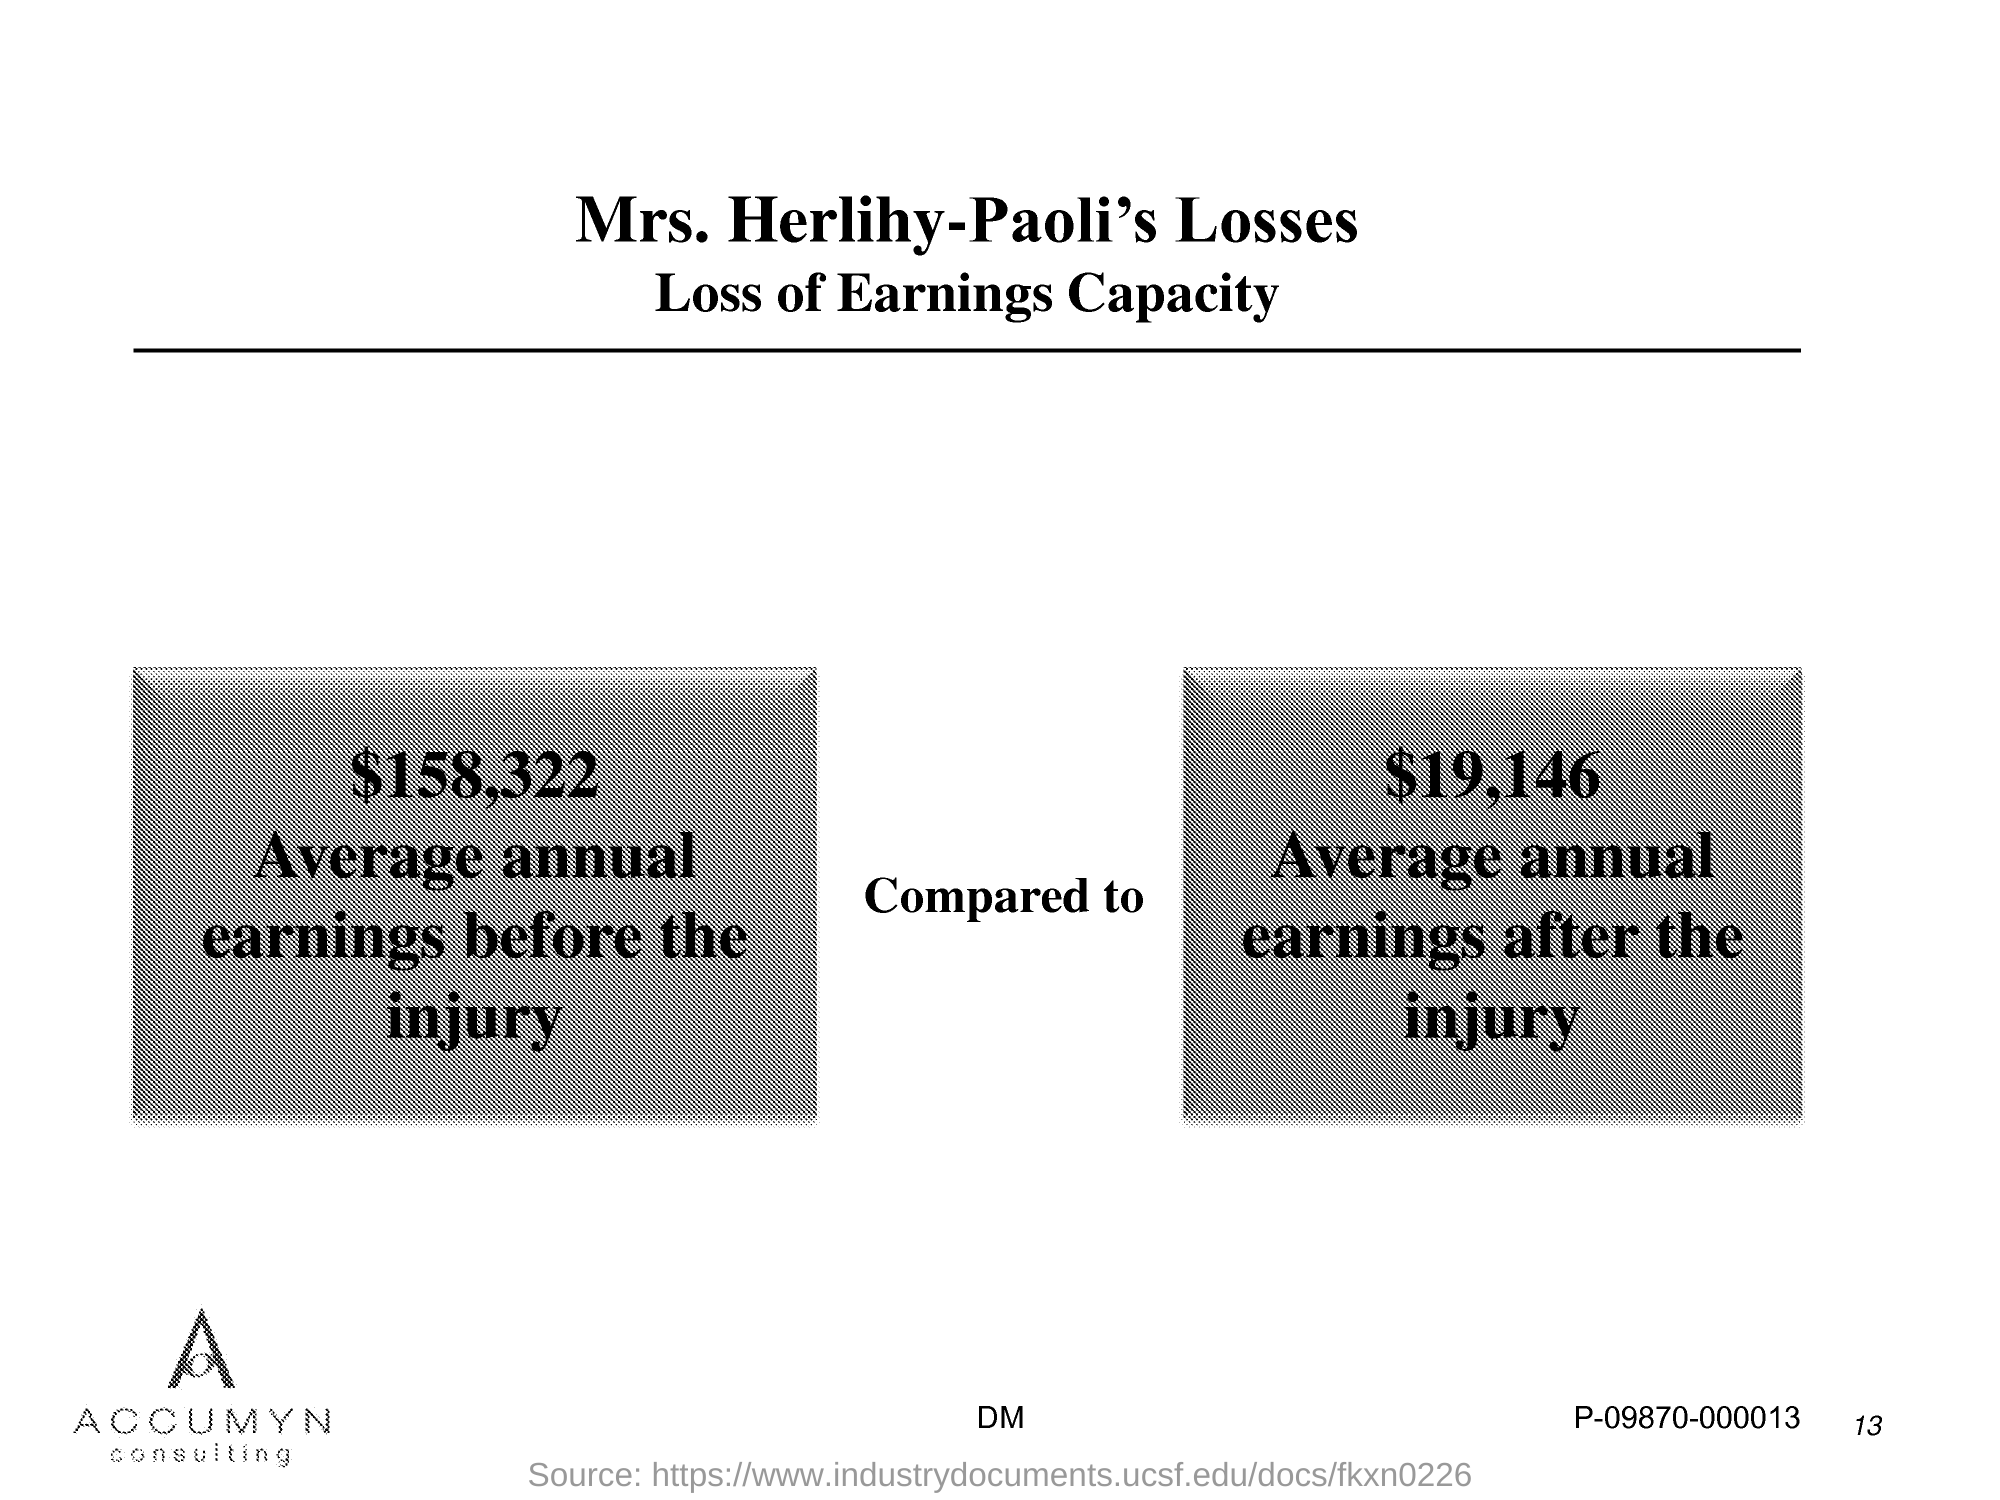List a handful of essential elements in this visual. The average annual earnings before the injury was $158,322. The average annual earnings after the injury is $19,146. The page number mentioned in this document is 13. 